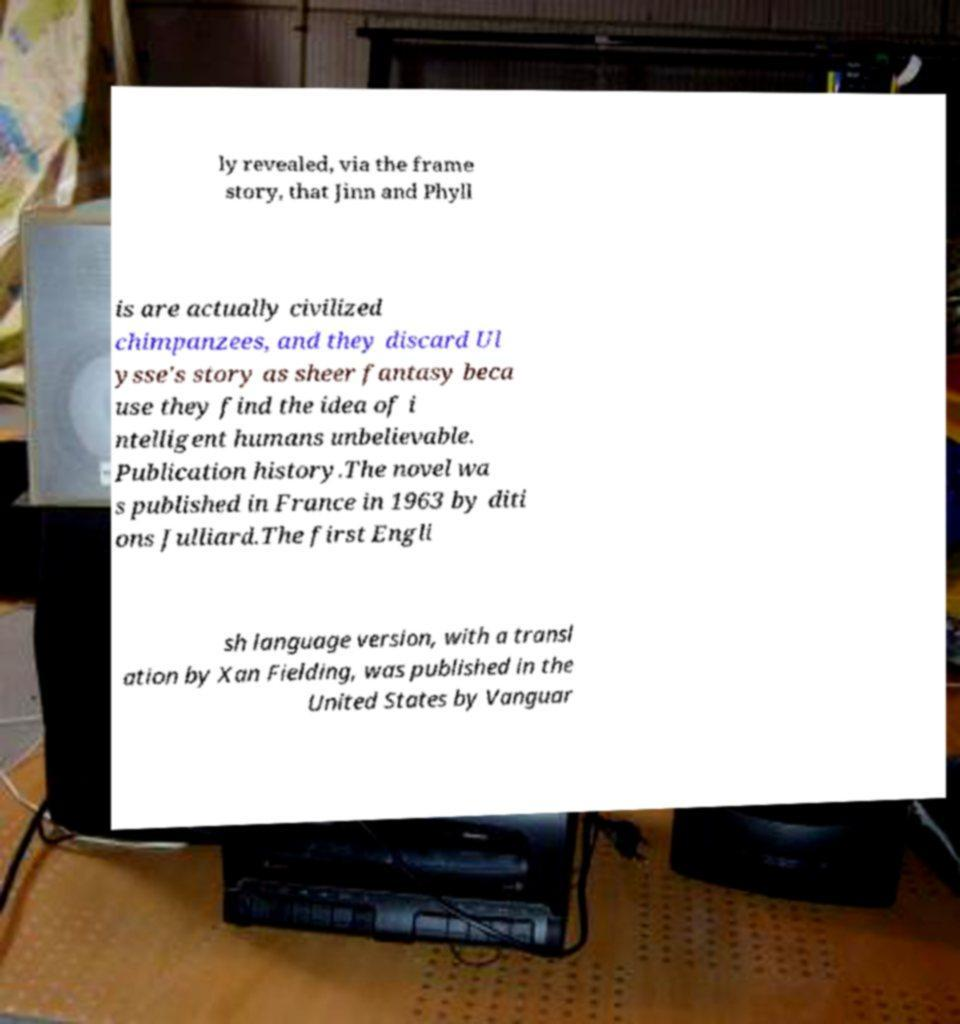Please read and relay the text visible in this image. What does it say? ly revealed, via the frame story, that Jinn and Phyll is are actually civilized chimpanzees, and they discard Ul ysse's story as sheer fantasy beca use they find the idea of i ntelligent humans unbelievable. Publication history.The novel wa s published in France in 1963 by diti ons Julliard.The first Engli sh language version, with a transl ation by Xan Fielding, was published in the United States by Vanguar 